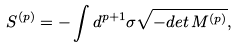<formula> <loc_0><loc_0><loc_500><loc_500>S ^ { ( p ) } = - \int d ^ { p + 1 } \sigma \sqrt { - d e t \, M ^ { ( p ) } } ,</formula> 